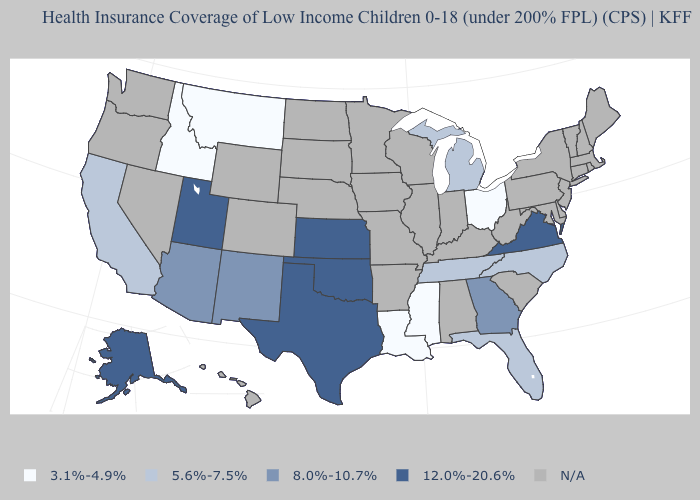Name the states that have a value in the range 5.6%-7.5%?
Quick response, please. California, Florida, Michigan, North Carolina, Tennessee. What is the lowest value in the West?
Short answer required. 3.1%-4.9%. What is the value of North Carolina?
Concise answer only. 5.6%-7.5%. How many symbols are there in the legend?
Write a very short answer. 5. Is the legend a continuous bar?
Answer briefly. No. What is the value of Delaware?
Be succinct. N/A. Does the first symbol in the legend represent the smallest category?
Concise answer only. Yes. Name the states that have a value in the range 3.1%-4.9%?
Keep it brief. Idaho, Louisiana, Mississippi, Montana, Ohio. Does Alaska have the highest value in the USA?
Keep it brief. Yes. Which states have the highest value in the USA?
Short answer required. Alaska, Kansas, Oklahoma, Texas, Utah, Virginia. What is the lowest value in the South?
Give a very brief answer. 3.1%-4.9%. What is the value of Iowa?
Concise answer only. N/A. Name the states that have a value in the range 8.0%-10.7%?
Give a very brief answer. Arizona, Georgia, New Mexico. Among the states that border Oklahoma , which have the lowest value?
Be succinct. New Mexico. Does Mississippi have the lowest value in the USA?
Keep it brief. Yes. 